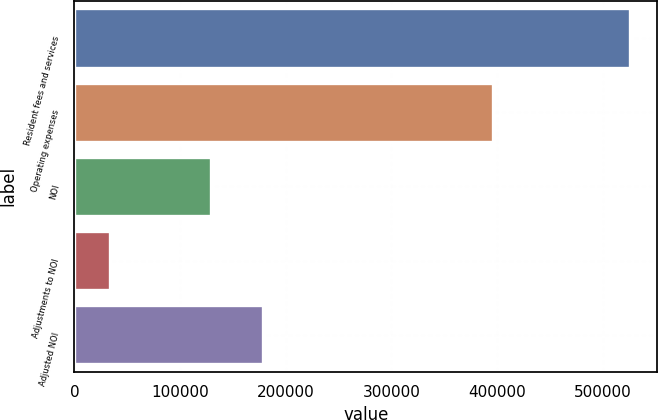<chart> <loc_0><loc_0><loc_500><loc_500><bar_chart><fcel>Resident fees and services<fcel>Operating expenses<fcel>NOI<fcel>Adjustments to NOI<fcel>Adjusted NOI<nl><fcel>525473<fcel>396491<fcel>128982<fcel>33227<fcel>178207<nl></chart> 